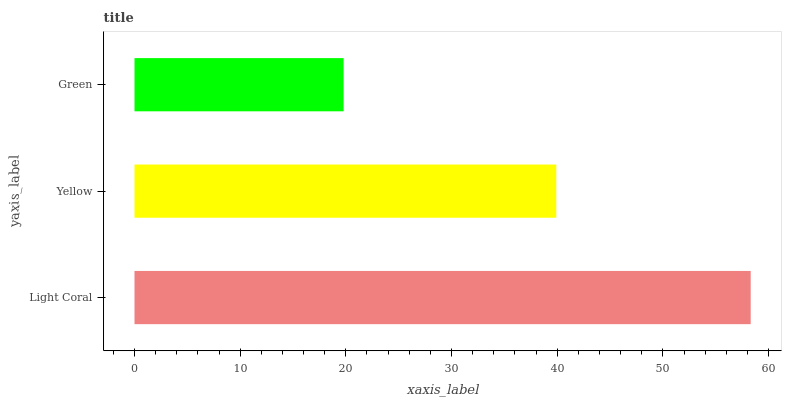Is Green the minimum?
Answer yes or no. Yes. Is Light Coral the maximum?
Answer yes or no. Yes. Is Yellow the minimum?
Answer yes or no. No. Is Yellow the maximum?
Answer yes or no. No. Is Light Coral greater than Yellow?
Answer yes or no. Yes. Is Yellow less than Light Coral?
Answer yes or no. Yes. Is Yellow greater than Light Coral?
Answer yes or no. No. Is Light Coral less than Yellow?
Answer yes or no. No. Is Yellow the high median?
Answer yes or no. Yes. Is Yellow the low median?
Answer yes or no. Yes. Is Green the high median?
Answer yes or no. No. Is Green the low median?
Answer yes or no. No. 